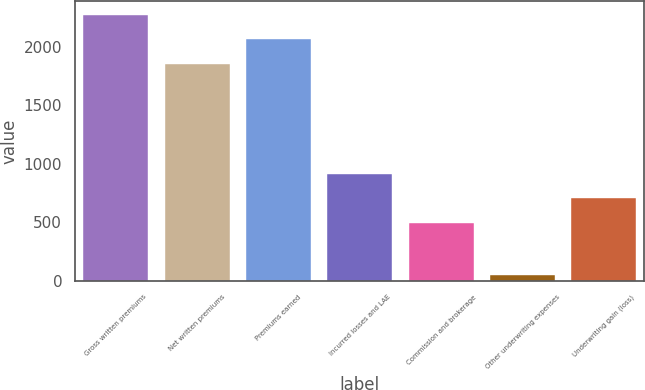Convert chart to OTSL. <chart><loc_0><loc_0><loc_500><loc_500><bar_chart><fcel>Gross written premiums<fcel>Net written premiums<fcel>Premiums earned<fcel>Incurred losses and LAE<fcel>Commission and brokerage<fcel>Other underwriting expenses<fcel>Underwriting gain (loss)<nl><fcel>2275.46<fcel>1855.9<fcel>2065.68<fcel>912.86<fcel>493.3<fcel>50.1<fcel>703.08<nl></chart> 